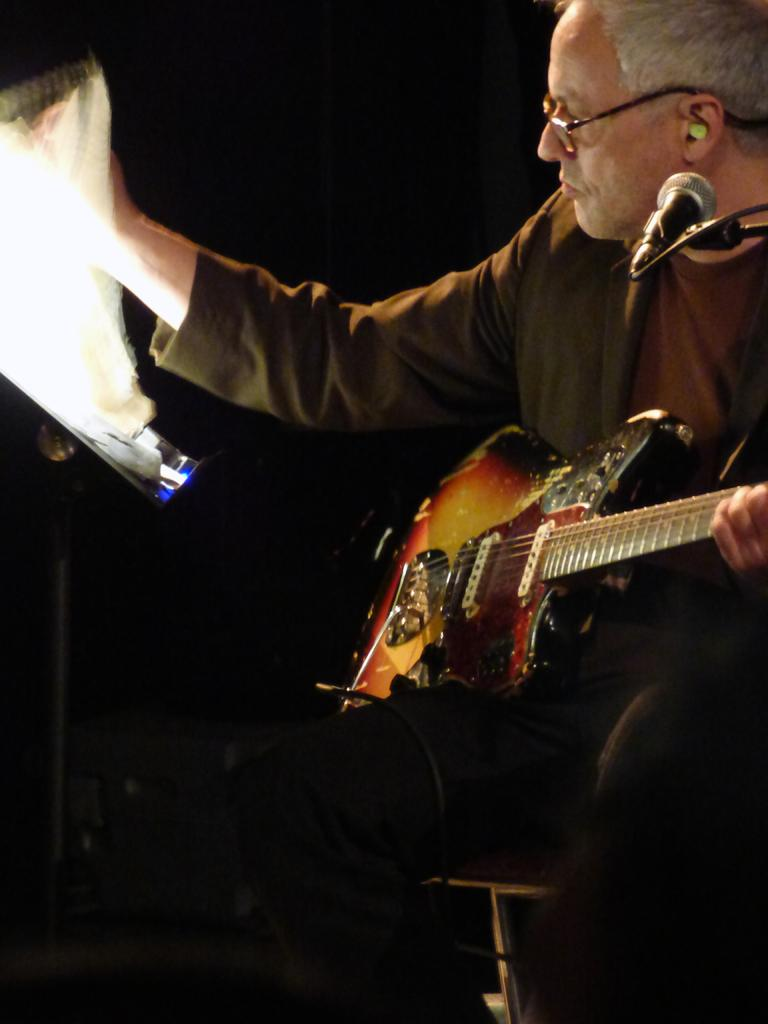What is the man in the image doing? The man is holding a guitar in the image. What is the man sitting on in the image? The man is sitting on a chair in the image. What type of lettuce can be seen growing on the street in the image? There is no lettuce or street present in the image; it features a man holding a guitar while sitting on a chair. 